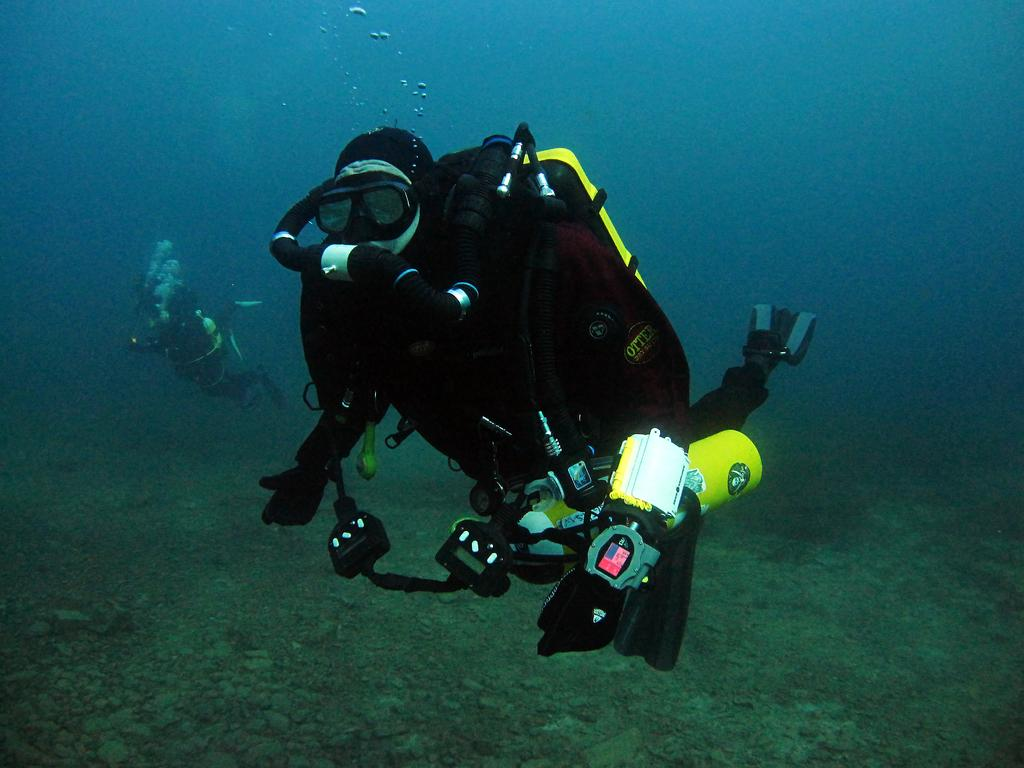How many people are in the image? There are two persons in the image. Where are the persons located in the image? The persons are underwater in the image. What equipment are the persons using to breathe underwater? The persons are using oxygen cylinders in the image. What type of footwear are the persons wearing? The persons are wearing swim fins in the image. What type of toys can be seen in the hands of the beggar in the image? There is no beggar or toys present in the image; it features two persons underwater using oxygen cylinders and wearing swim fins. 